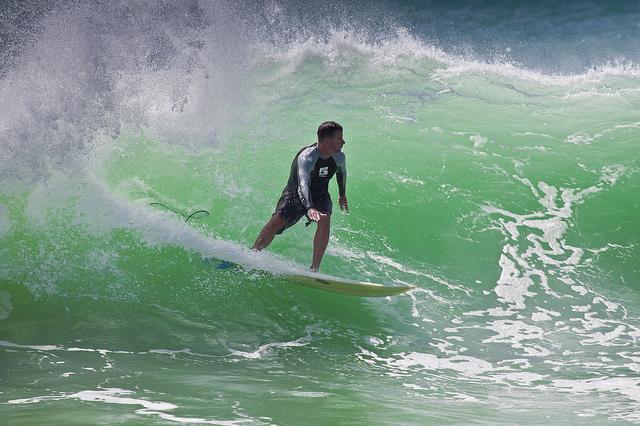How many people are in the water?
Concise answer only. 1. What is this man on?
Keep it brief. Surfboard. Is this a big wave?
Be succinct. Yes. What color is the water?
Write a very short answer. Green. What colors is his wetsuit?
Answer briefly. Black and silver. 